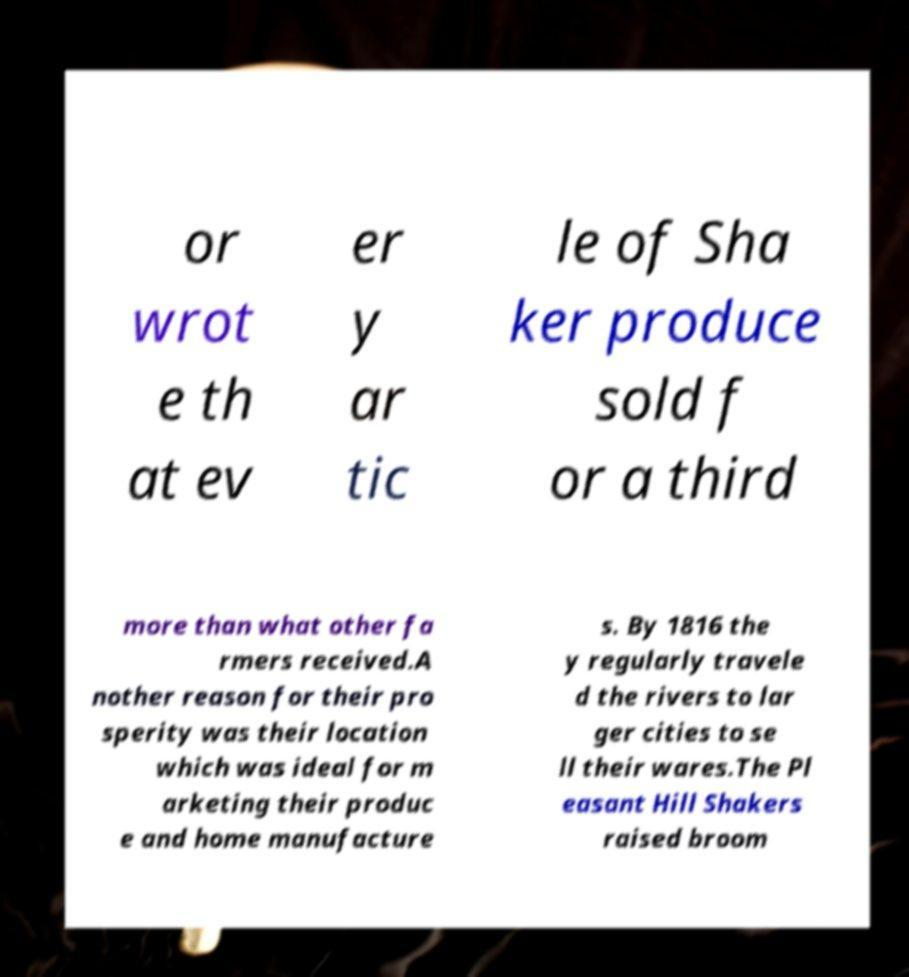Could you extract and type out the text from this image? or wrot e th at ev er y ar tic le of Sha ker produce sold f or a third more than what other fa rmers received.A nother reason for their pro sperity was their location which was ideal for m arketing their produc e and home manufacture s. By 1816 the y regularly travele d the rivers to lar ger cities to se ll their wares.The Pl easant Hill Shakers raised broom 